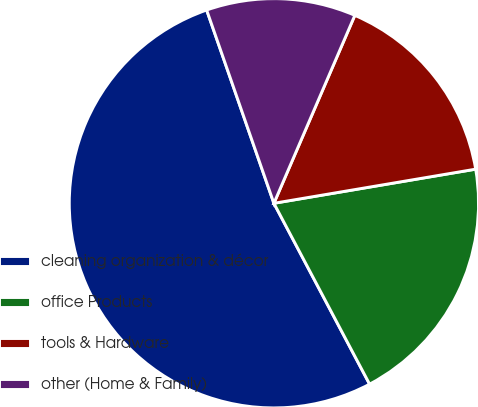Convert chart to OTSL. <chart><loc_0><loc_0><loc_500><loc_500><pie_chart><fcel>cleaning organization & décor<fcel>office Products<fcel>tools & Hardware<fcel>other (Home & Family)<nl><fcel>52.41%<fcel>19.92%<fcel>15.86%<fcel>11.8%<nl></chart> 